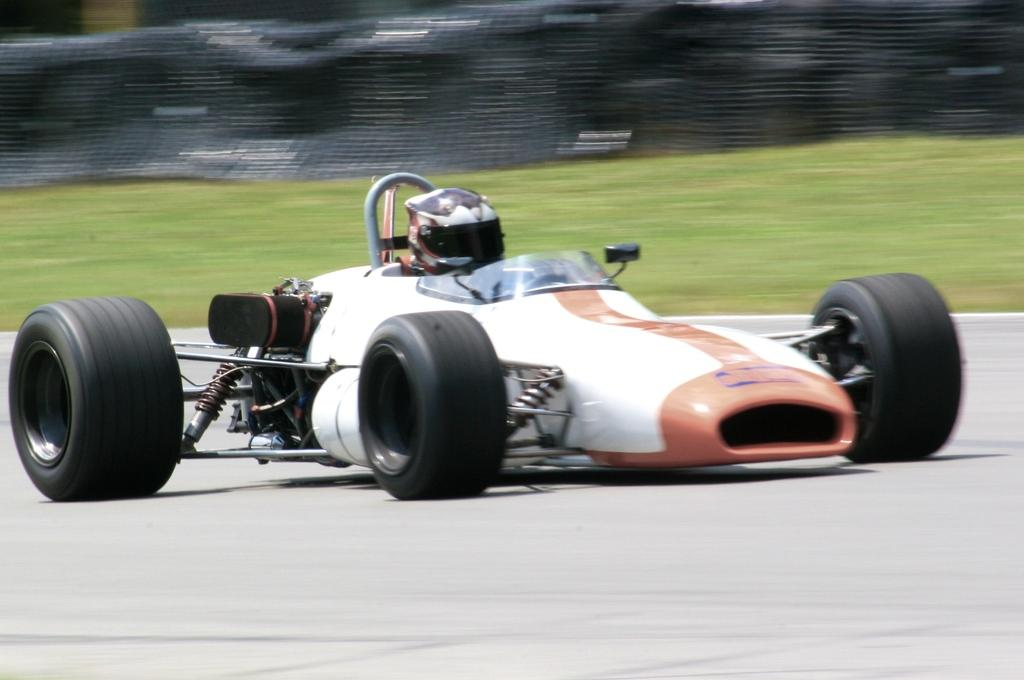What is the main subject of the image? There is a racing car in the image. Who is inside the racing car? A person is sitting in the car. What protective gear is the person wearing? The person is wearing a helmet. What type of terrain is visible in the image? There is grass visible on the ground in the image. How many toys are scattered around the racing car in the image? There are no toys present in the image. What is the minister doing in the image? There is no minister present in the image. 